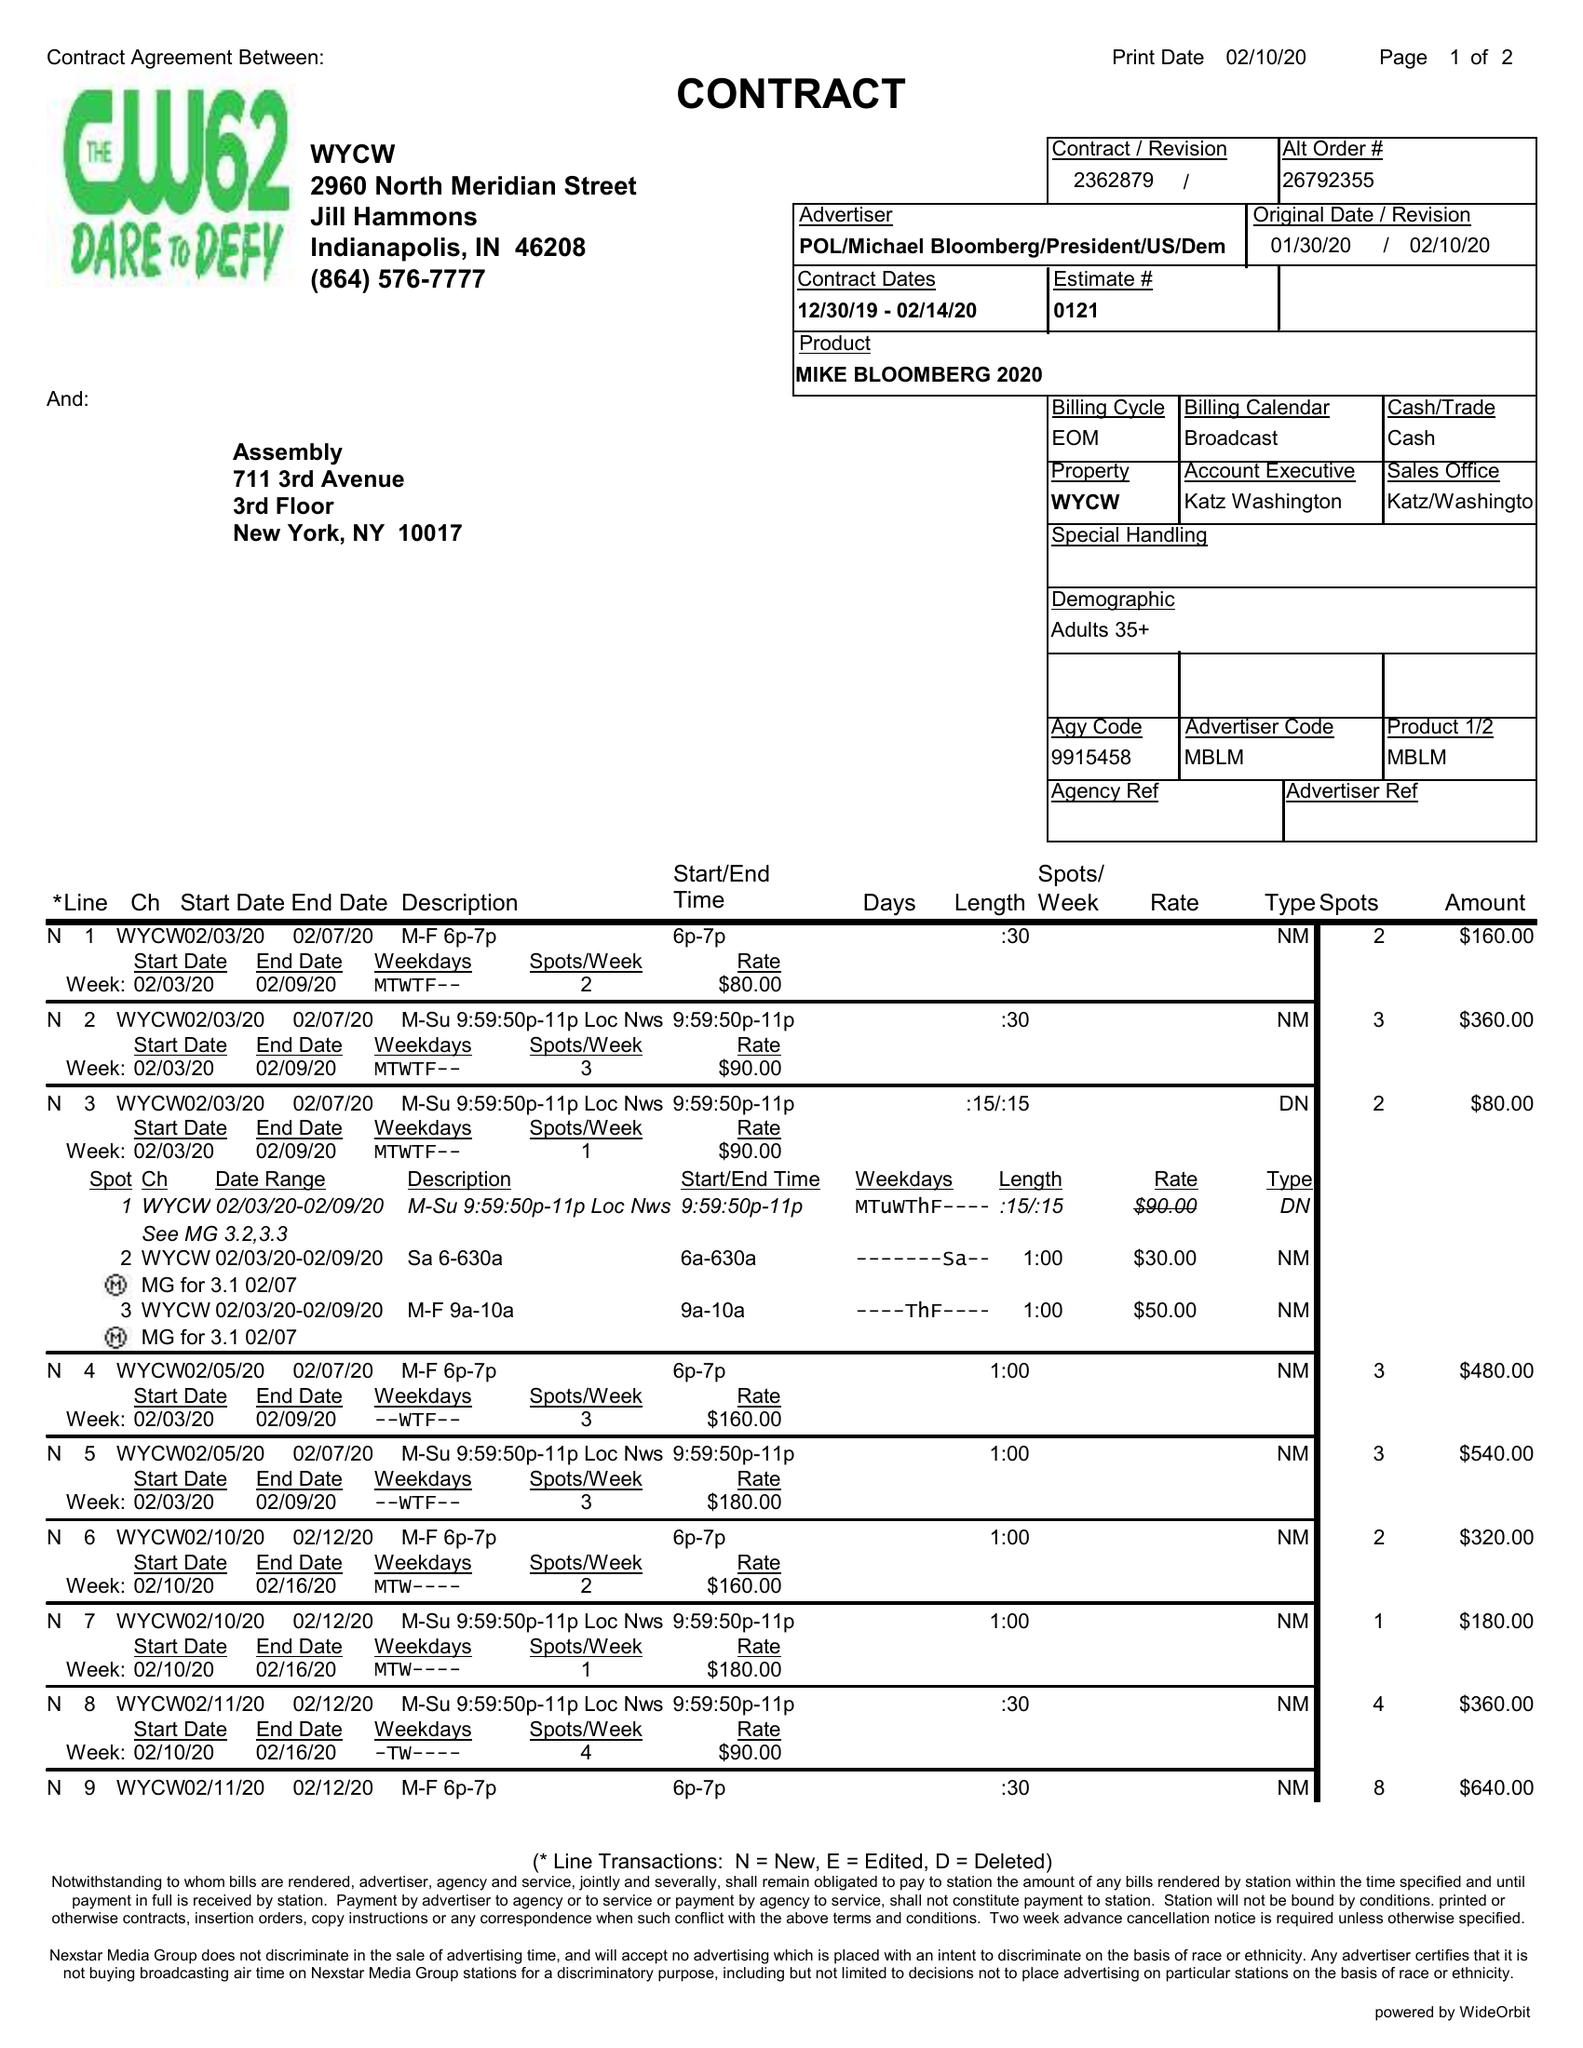What is the value for the flight_from?
Answer the question using a single word or phrase. 12/30/19 